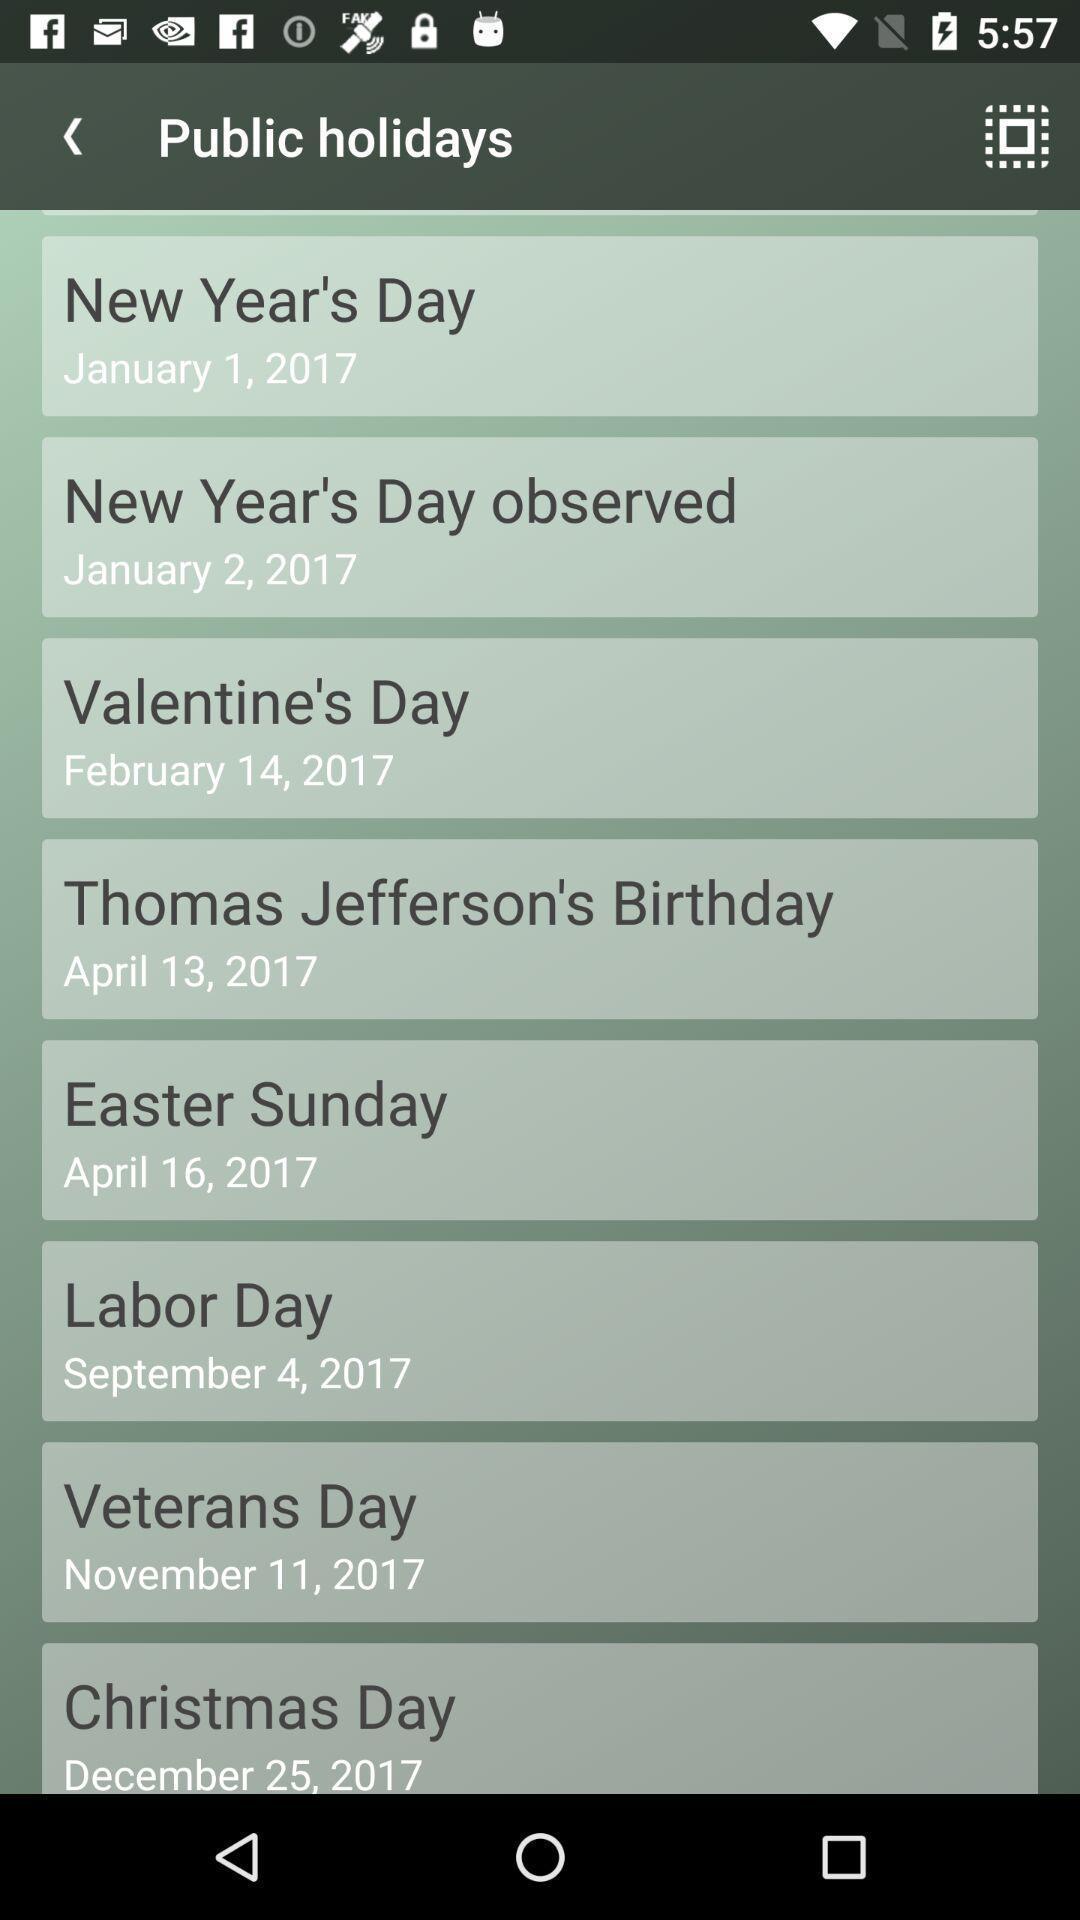Provide a textual representation of this image. Screen shows holidays list in a calendar app. 